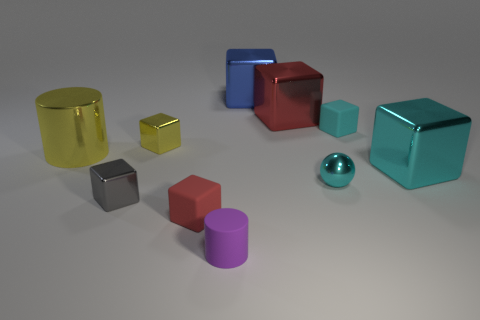Subtract all red cubes. How many were subtracted if there are1red cubes left? 1 Subtract all yellow blocks. How many blocks are left? 6 Subtract all small matte blocks. How many blocks are left? 5 Subtract all yellow cubes. How many yellow cylinders are left? 1 Subtract all cubes. How many objects are left? 3 Subtract 5 cubes. How many cubes are left? 2 Subtract all cyan cubes. Subtract all red balls. How many cubes are left? 5 Subtract all brown rubber blocks. Subtract all small cyan metallic spheres. How many objects are left? 9 Add 8 blue cubes. How many blue cubes are left? 9 Add 4 small red things. How many small red things exist? 5 